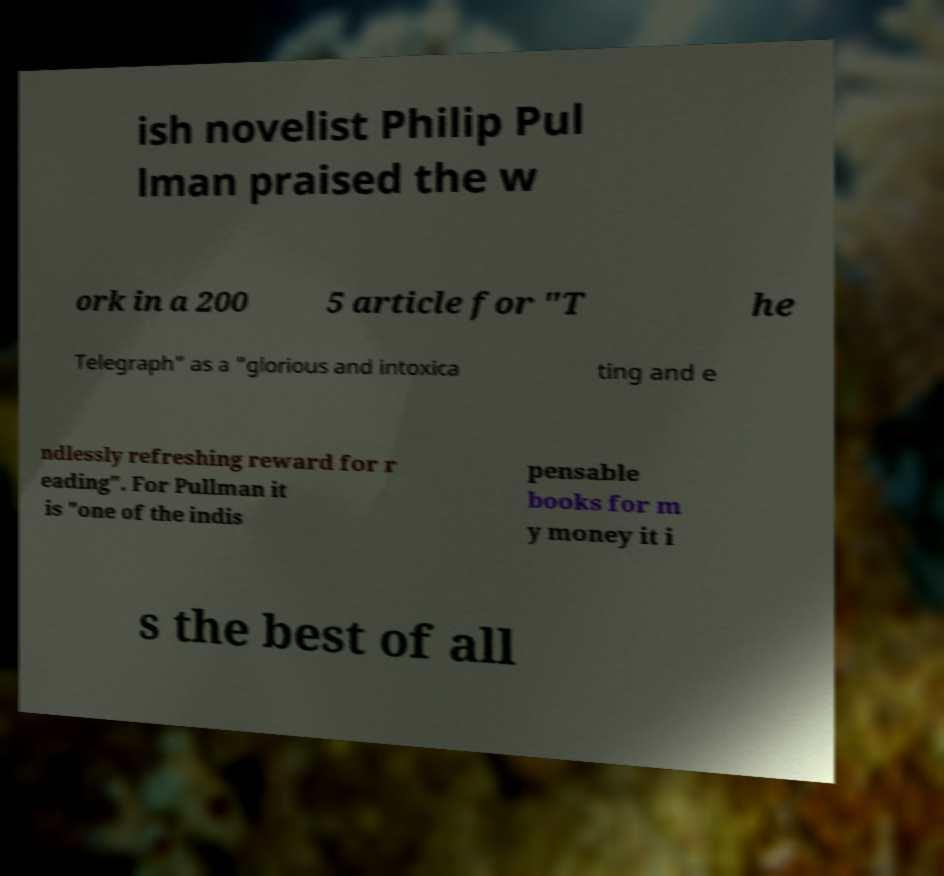Could you assist in decoding the text presented in this image and type it out clearly? ish novelist Philip Pul lman praised the w ork in a 200 5 article for "T he Telegraph" as a "glorious and intoxica ting and e ndlessly refreshing reward for r eading". For Pullman it is "one of the indis pensable books for m y money it i s the best of all 